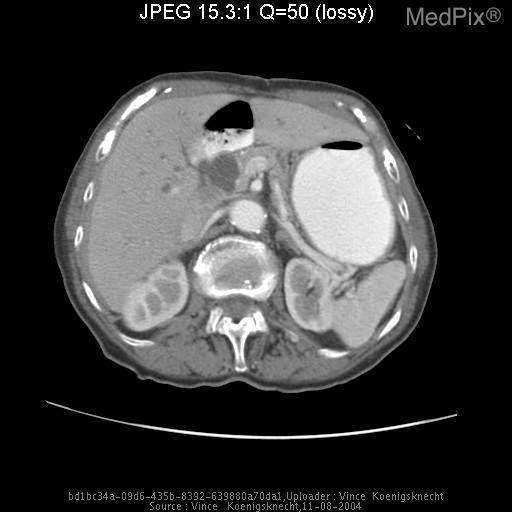What are those densities in the wall of the aorta?
Give a very brief answer. Calcifications. Is the liver normal in size?
Keep it brief. No. What are these hypodensities in the liver?
Short answer required. Fat accumulations. 